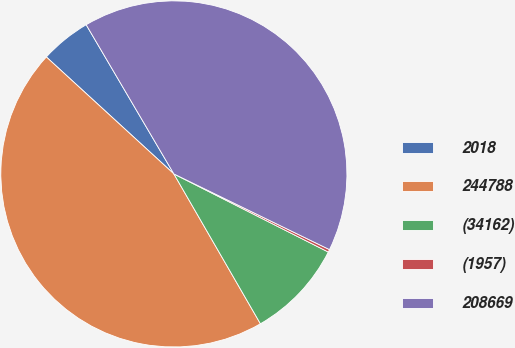<chart> <loc_0><loc_0><loc_500><loc_500><pie_chart><fcel>2018<fcel>244788<fcel>(34162)<fcel>(1957)<fcel>208669<nl><fcel>4.73%<fcel>45.15%<fcel>9.21%<fcel>0.25%<fcel>40.67%<nl></chart> 